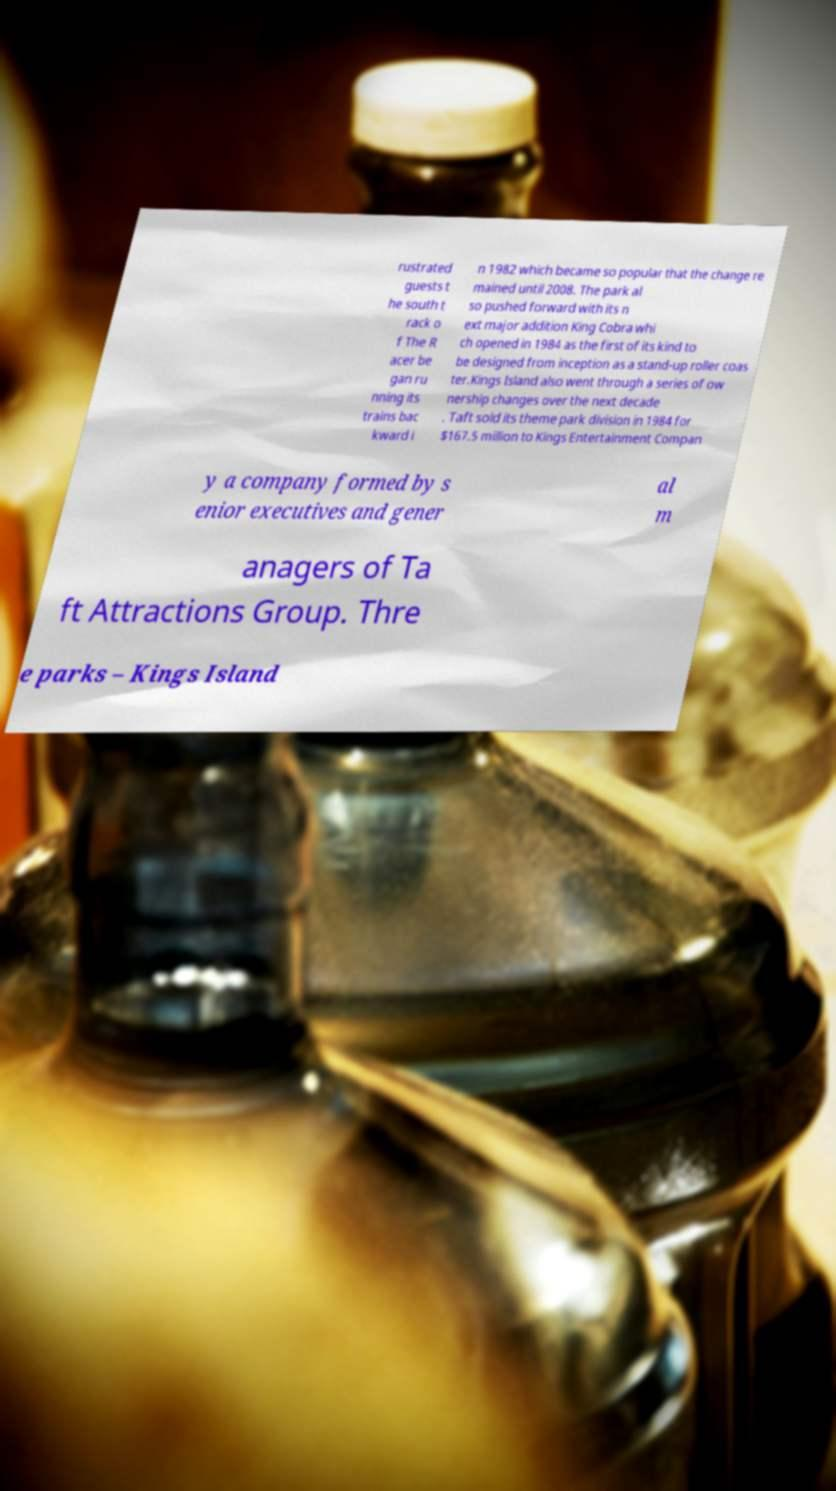There's text embedded in this image that I need extracted. Can you transcribe it verbatim? rustrated guests t he south t rack o f The R acer be gan ru nning its trains bac kward i n 1982 which became so popular that the change re mained until 2008. The park al so pushed forward with its n ext major addition King Cobra whi ch opened in 1984 as the first of its kind to be designed from inception as a stand-up roller coas ter.Kings Island also went through a series of ow nership changes over the next decade . Taft sold its theme park division in 1984 for $167.5 million to Kings Entertainment Compan y a company formed by s enior executives and gener al m anagers of Ta ft Attractions Group. Thre e parks – Kings Island 